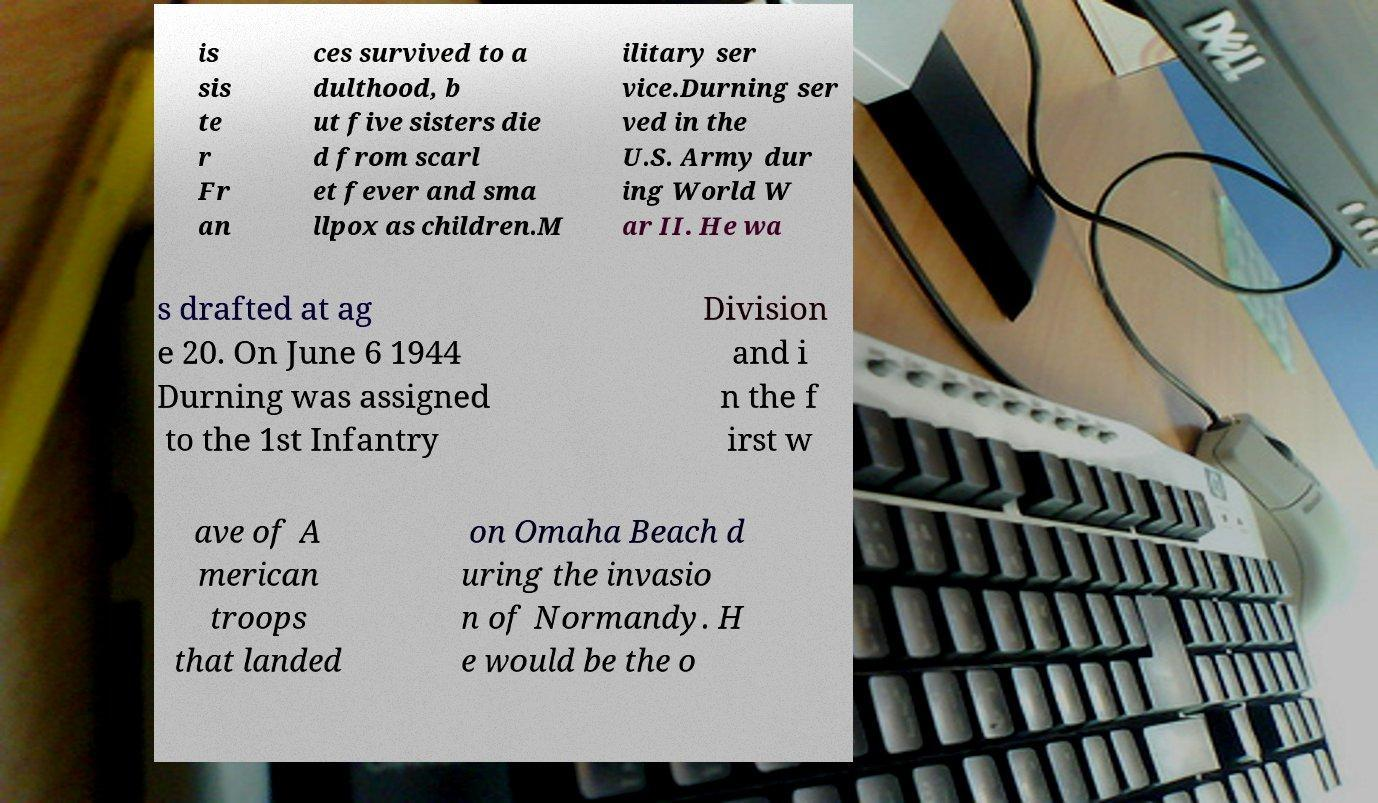There's text embedded in this image that I need extracted. Can you transcribe it verbatim? is sis te r Fr an ces survived to a dulthood, b ut five sisters die d from scarl et fever and sma llpox as children.M ilitary ser vice.Durning ser ved in the U.S. Army dur ing World W ar II. He wa s drafted at ag e 20. On June 6 1944 Durning was assigned to the 1st Infantry Division and i n the f irst w ave of A merican troops that landed on Omaha Beach d uring the invasio n of Normandy. H e would be the o 